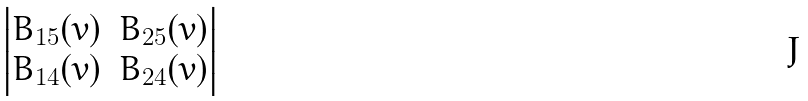Convert formula to latex. <formula><loc_0><loc_0><loc_500><loc_500>\begin{vmatrix} B _ { 1 5 } ( v ) & B _ { 2 5 } ( v ) \\ B _ { 1 4 } ( v ) & B _ { 2 4 } ( v ) \end{vmatrix}</formula> 